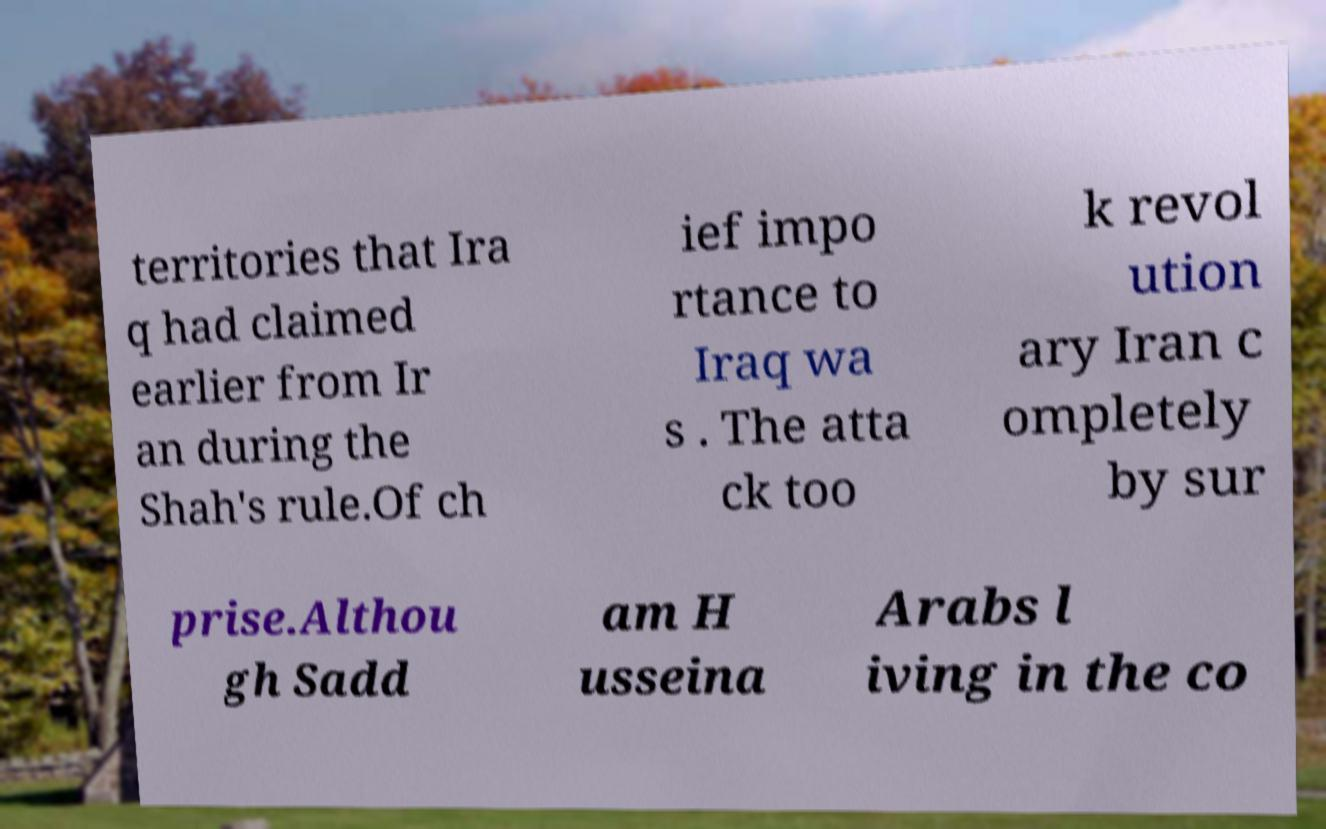Could you assist in decoding the text presented in this image and type it out clearly? territories that Ira q had claimed earlier from Ir an during the Shah's rule.Of ch ief impo rtance to Iraq wa s . The atta ck too k revol ution ary Iran c ompletely by sur prise.Althou gh Sadd am H usseina Arabs l iving in the co 